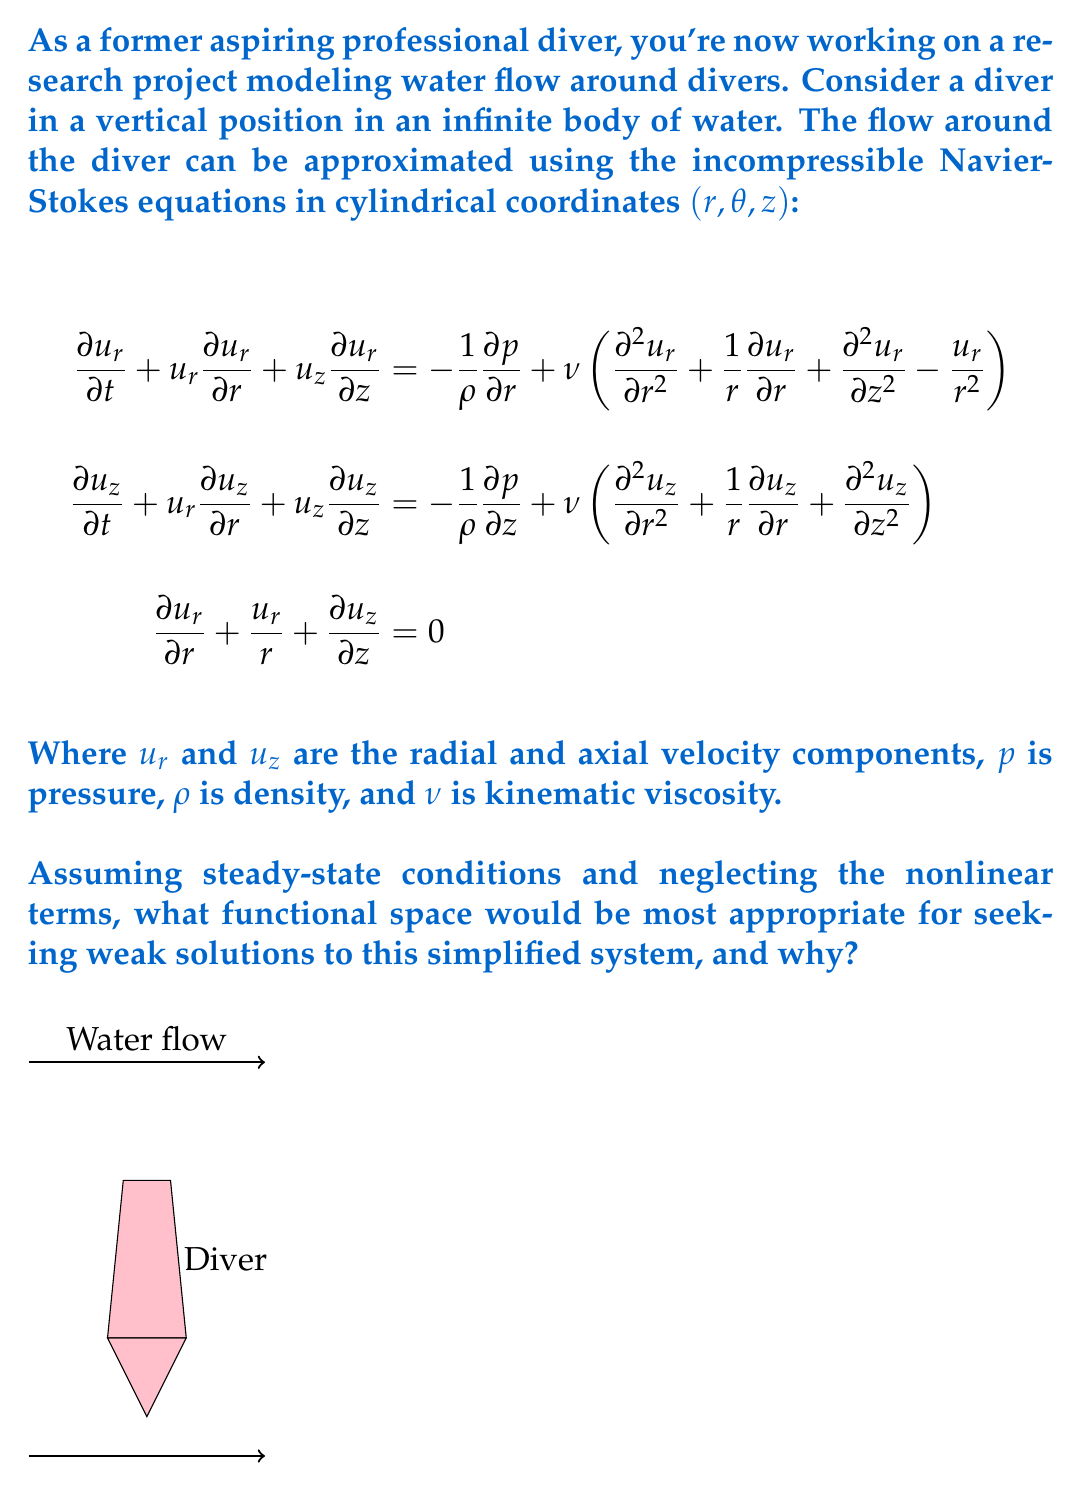Teach me how to tackle this problem. To determine the most appropriate functional space for weak solutions, let's analyze the simplified system:

1) Under steady-state conditions, $\frac{\partial u_r}{\partial t} = \frac{\partial u_z}{\partial t} = 0$.

2) Neglecting nonlinear terms, we remove $u_r\frac{\partial u_r}{\partial r}$, $u_z\frac{\partial u_r}{\partial z}$, $u_r\frac{\partial u_z}{\partial r}$, and $u_z\frac{\partial u_z}{\partial z}$.

3) The simplified system becomes:

   $$-\frac{1}{\rho}\frac{\partial p}{\partial r} + \nu\left(\frac{\partial^2 u_r}{\partial r^2} + \frac{1}{r}\frac{\partial u_r}{\partial r} + \frac{\partial^2 u_r}{\partial z^2} - \frac{u_r}{r^2}\right) = 0$$
   $$-\frac{1}{\rho}\frac{\partial p}{\partial z} + \nu\left(\frac{\partial^2 u_z}{\partial r^2} + \frac{1}{r}\frac{\partial u_z}{\partial r} + \frac{\partial^2 u_z}{\partial z^2}\right) = 0$$
   $$\frac{\partial u_r}{\partial r} + \frac{u_r}{r} + \frac{\partial u_z}{\partial z} = 0$$

4) This system is now linear and elliptic, containing second-order partial derivatives.

5) For elliptic PDEs, the natural choice for weak solutions is the Sobolev space $H^1(\Omega)$, where $\Omega$ is the domain of interest.

6) $H^1(\Omega)$ is defined as:
   $$H^1(\Omega) = \{u \in L^2(\Omega) : \frac{\partial u}{\partial x_i} \in L^2(\Omega) \text{ for } i=1,\ldots,n\}$$

7) This space is appropriate because:
   a) It allows for weak derivatives up to first order, which appear in the variational formulation of the problem.
   b) It ensures square integrability of both the function and its first derivatives, which is necessary for the energy estimates in the weak formulation.
   c) It provides the right balance between regularity and generality for elliptic problems.

8) Moreover, to account for the divergence-free condition (incompressibility), we should consider a subspace of $H^1(\Omega)$:
   $$V = \{v \in [H^1(\Omega)]^2 : \nabla \cdot v = 0\}$$

9) For the pressure term, we typically use $L^2(\Omega)$, as it only appears with first-order derivatives in the equations.

Therefore, the most appropriate functional space for seeking weak solutions to this simplified system would be $V \times L^2(\Omega)$ for velocity and pressure, respectively.
Answer: $V \times L^2(\Omega)$, where $V = \{v \in [H^1(\Omega)]^2 : \nabla \cdot v = 0\}$ 